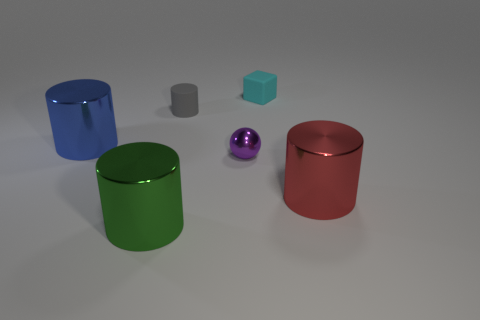Subtract all tiny gray cylinders. How many cylinders are left? 3 Add 3 green things. How many objects exist? 9 Subtract all blue cylinders. How many cylinders are left? 3 Subtract 3 cylinders. How many cylinders are left? 1 Add 1 large purple rubber objects. How many large purple rubber objects exist? 1 Subtract 1 green cylinders. How many objects are left? 5 Subtract all cylinders. How many objects are left? 2 Subtract all brown cubes. Subtract all yellow spheres. How many cubes are left? 1 Subtract all big purple rubber things. Subtract all small gray matte objects. How many objects are left? 5 Add 5 green cylinders. How many green cylinders are left? 6 